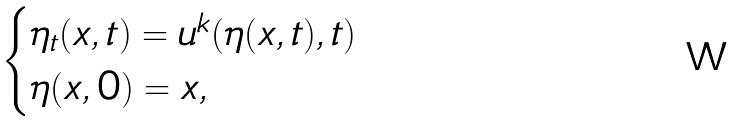Convert formula to latex. <formula><loc_0><loc_0><loc_500><loc_500>\begin{cases} \eta _ { t } ( x , t ) = u ^ { k } ( \eta ( x , t ) , t ) \\ \eta ( x , 0 ) = x , \end{cases}</formula> 